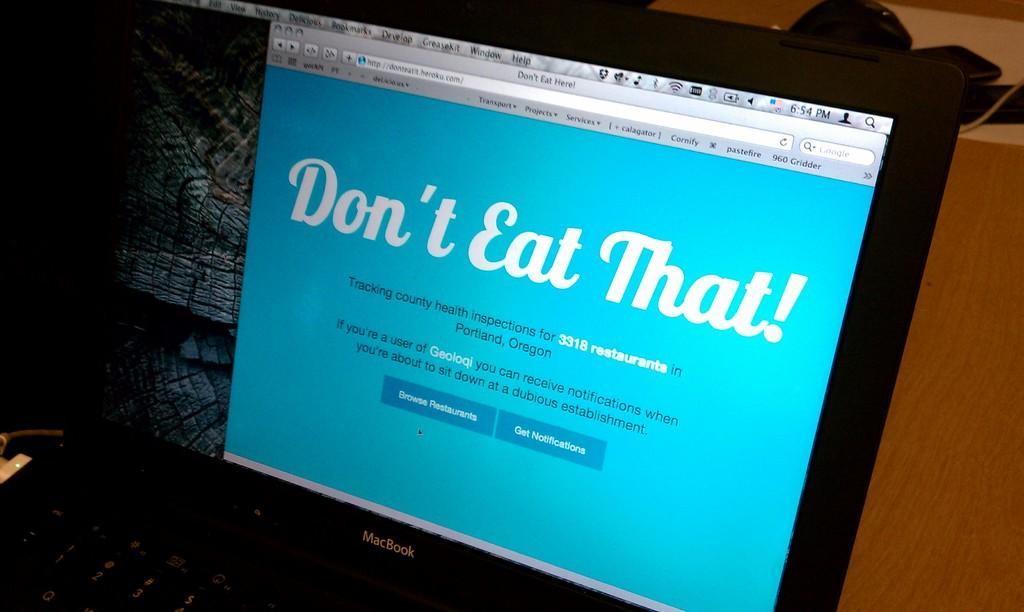Provide a one-sentence caption for the provided image. A laptop open to a webpage telling the user "Don't Eat That!". 